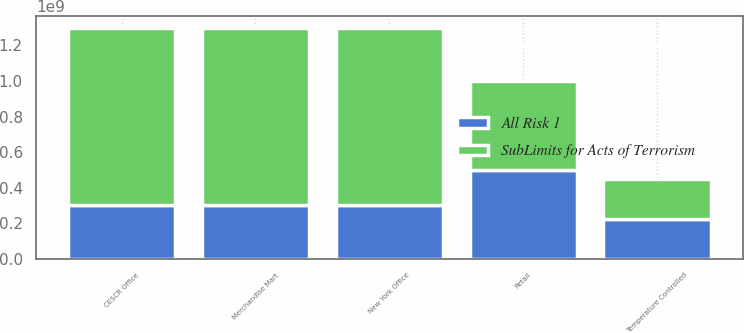Convert chart. <chart><loc_0><loc_0><loc_500><loc_500><stacked_bar_chart><ecel><fcel>New York Office<fcel>CESCR Office<fcel>Retail<fcel>Merchandise Mart<fcel>Temperature Controlled<nl><fcel>SubLimits for Acts of Terrorism<fcel>1e+09<fcel>1e+09<fcel>5e+08<fcel>1e+09<fcel>2.25e+08<nl><fcel>All Risk 1<fcel>3e+08<fcel>3e+08<fcel>5e+08<fcel>3e+08<fcel>2.25e+08<nl></chart> 